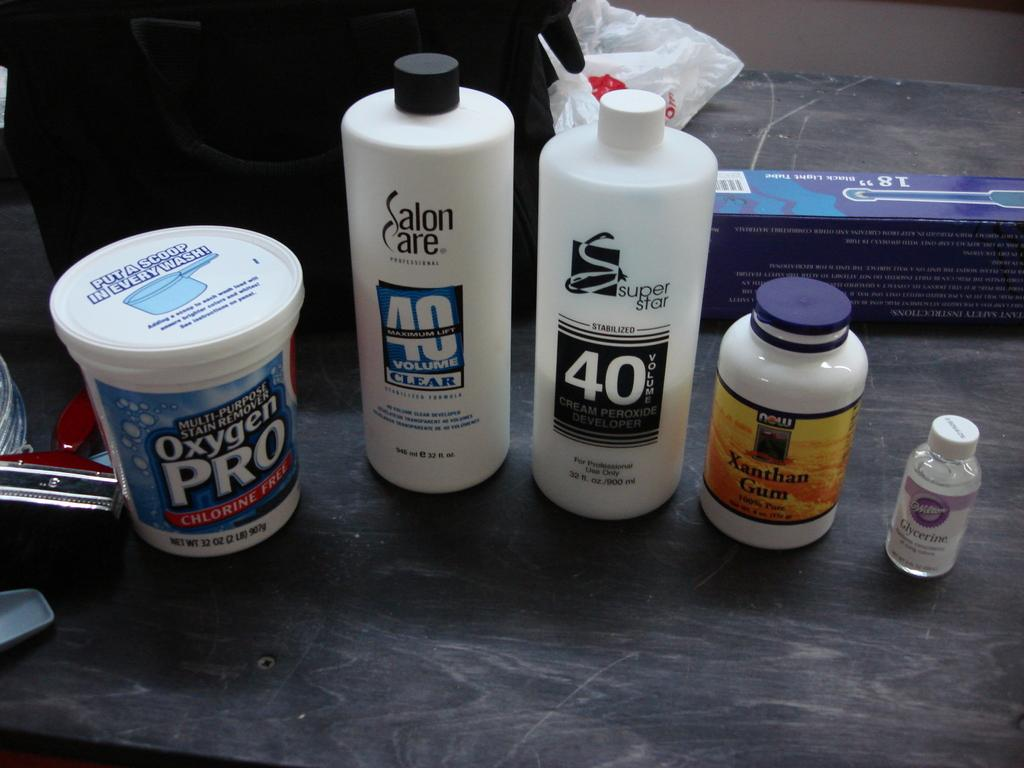How many white bottles are visible in the image? There are five white bottles in the image. Where are the white bottles located? The bottles are placed on a table. What type of notebook is placed next to the white bottles in the image? There is no notebook present in the image. What level of comfort can be observed from the image? The image does not convey any information about comfort. 